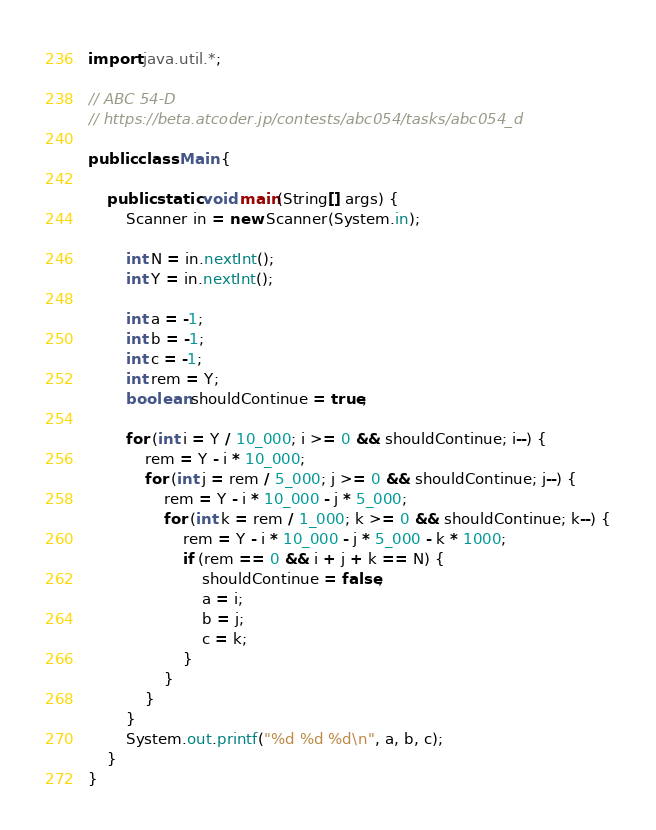Convert code to text. <code><loc_0><loc_0><loc_500><loc_500><_Java_>import java.util.*;

// ABC 54-D
// https://beta.atcoder.jp/contests/abc054/tasks/abc054_d

public class Main {

	public static void main(String[] args) {
		Scanner in = new Scanner(System.in);
		
		int N = in.nextInt();
		int Y = in.nextInt();
		
		int a = -1;
		int b = -1;
		int c = -1;
		int rem = Y;
		boolean shouldContinue = true;
		
		for (int i = Y / 10_000; i >= 0 && shouldContinue; i--) {
			rem = Y - i * 10_000;
			for (int j = rem / 5_000; j >= 0 && shouldContinue; j--) {
				rem = Y - i * 10_000 - j * 5_000;
				for (int k = rem / 1_000; k >= 0 && shouldContinue; k--) {
					rem = Y - i * 10_000 - j * 5_000 - k * 1000;
					if (rem == 0 && i + j + k == N) {
						shouldContinue = false;
						a = i;
						b = j;
						c = k;
					}
				}
			}
		}
		System.out.printf("%d %d %d\n", a, b, c);
	}
}</code> 